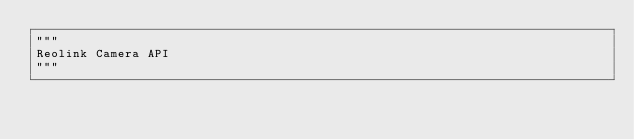Convert code to text. <code><loc_0><loc_0><loc_500><loc_500><_Python_>"""
Reolink Camera API
"""
</code> 